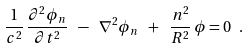Convert formula to latex. <formula><loc_0><loc_0><loc_500><loc_500>\frac { 1 } { c ^ { 2 } } \, \frac { \partial ^ { 2 } \phi _ { n } } { \partial t ^ { 2 } } \ - \ \nabla ^ { 2 } \phi _ { n } \ + \ \frac { n ^ { 2 } } { R ^ { 2 } } \, \phi = 0 \ .</formula> 